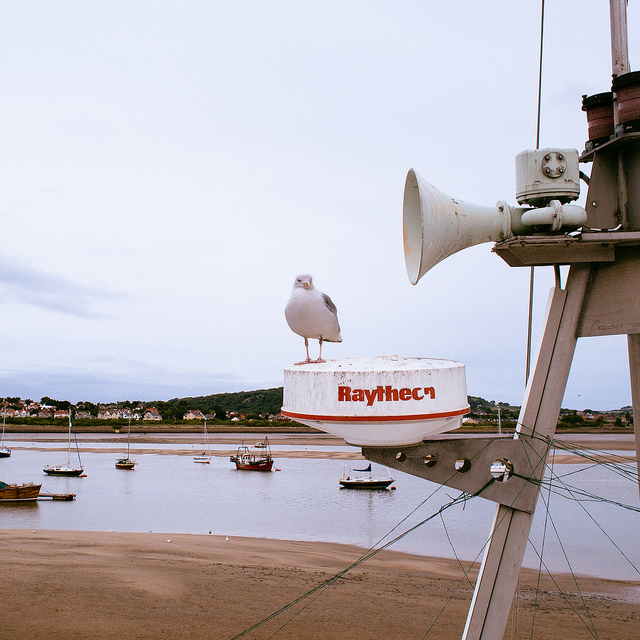Identify the text contained in this image. Raythecn 